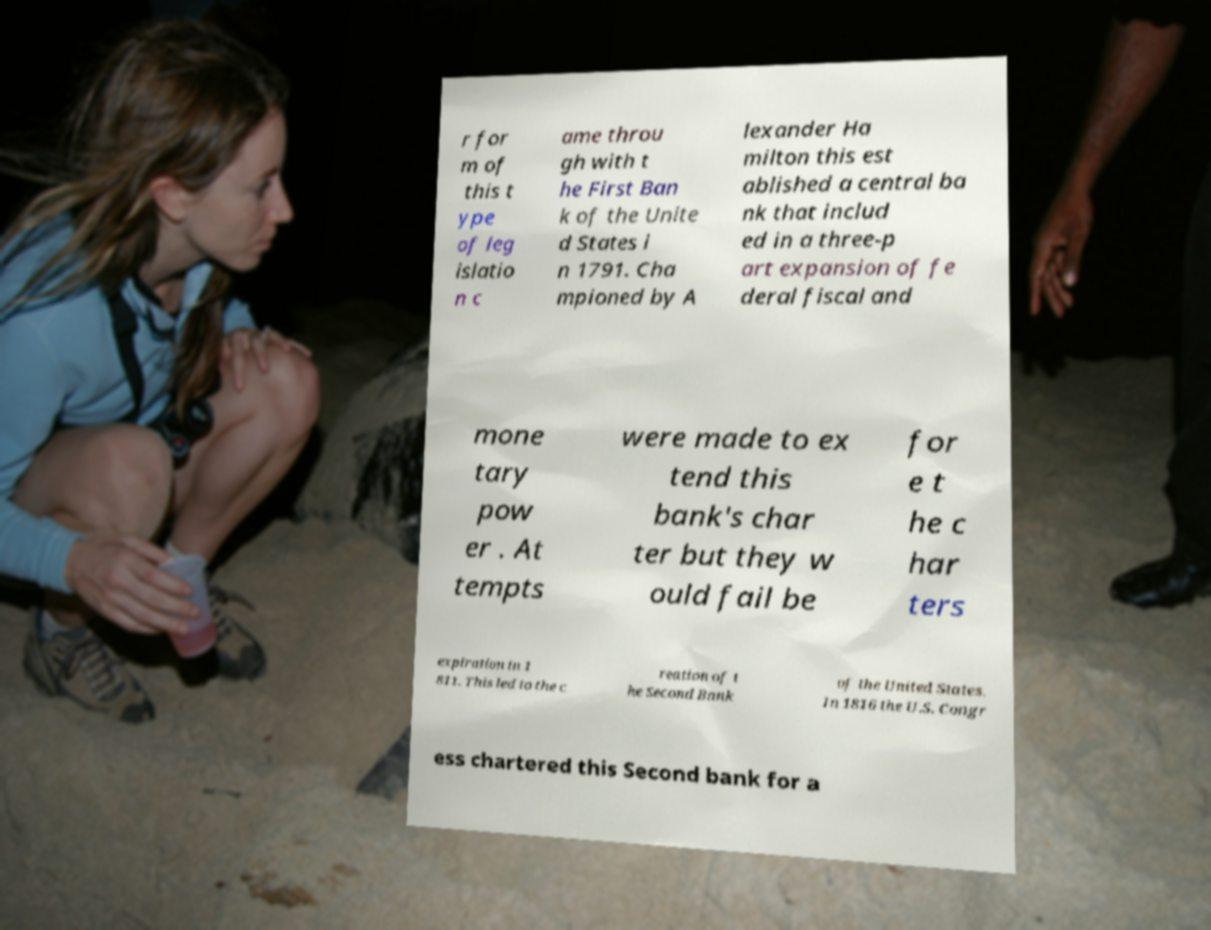What messages or text are displayed in this image? I need them in a readable, typed format. r for m of this t ype of leg islatio n c ame throu gh with t he First Ban k of the Unite d States i n 1791. Cha mpioned by A lexander Ha milton this est ablished a central ba nk that includ ed in a three-p art expansion of fe deral fiscal and mone tary pow er . At tempts were made to ex tend this bank's char ter but they w ould fail be for e t he c har ters expiration in 1 811. This led to the c reation of t he Second Bank of the United States. In 1816 the U.S. Congr ess chartered this Second bank for a 